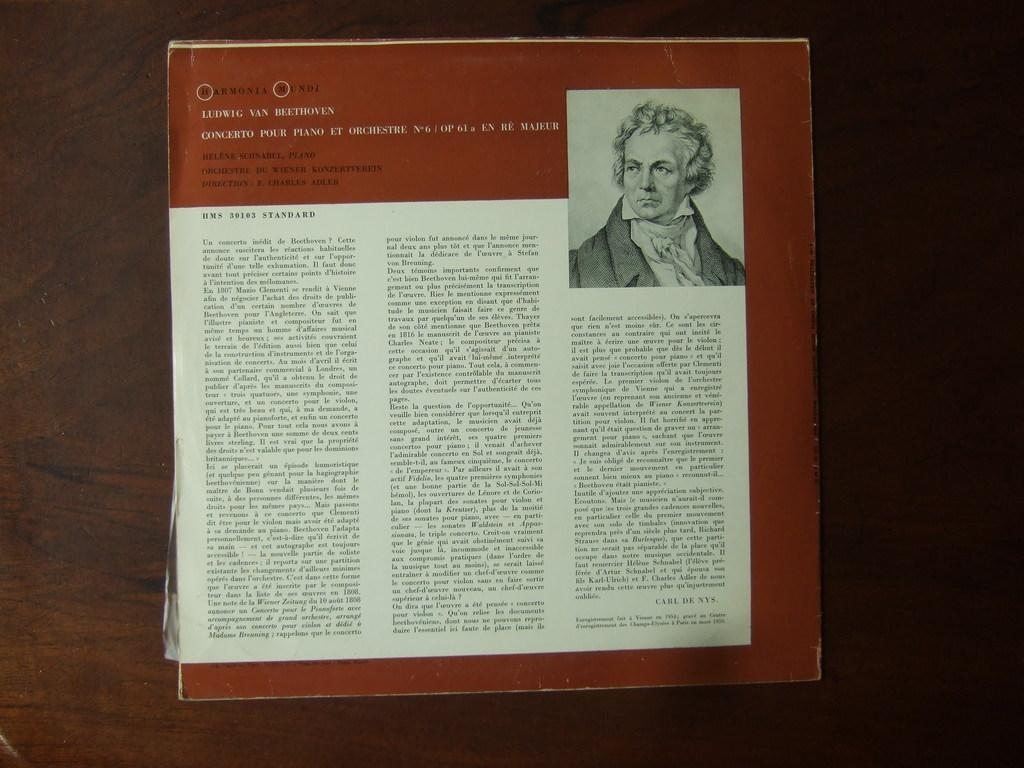What is the main subject in the center of the image? There is a paper in the center of the image. What is the paper placed on? The paper is on a wooden object. Can you describe the person visible in the image? There is a person visible in the image, but their appearance or actions are not specified. What can be read on the paper? There is text on the paper. What type of kite is the person flying in the image? There is no kite present in the image; it features a paper on a wooden object with a person nearby. What idea does the text on the paper represent? We cannot determine the idea represented by the text on the paper without reading it, and even then, it would be subjective. 